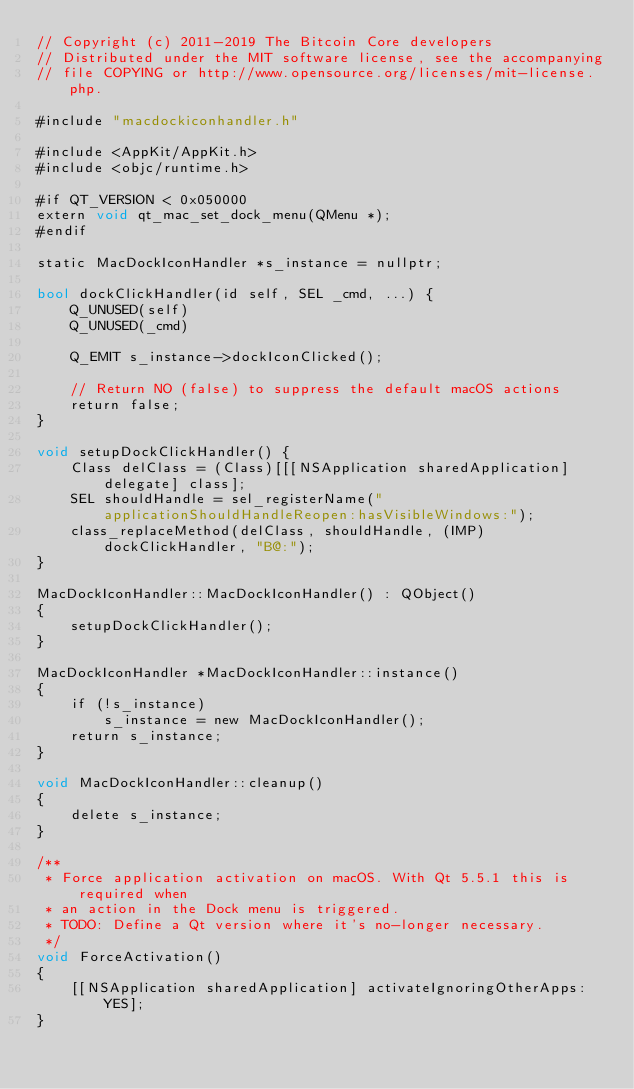Convert code to text. <code><loc_0><loc_0><loc_500><loc_500><_ObjectiveC_>// Copyright (c) 2011-2019 The Bitcoin Core developers
// Distributed under the MIT software license, see the accompanying
// file COPYING or http://www.opensource.org/licenses/mit-license.php.

#include "macdockiconhandler.h"

#include <AppKit/AppKit.h>
#include <objc/runtime.h>

#if QT_VERSION < 0x050000
extern void qt_mac_set_dock_menu(QMenu *);
#endif

static MacDockIconHandler *s_instance = nullptr;

bool dockClickHandler(id self, SEL _cmd, ...) {
    Q_UNUSED(self)
    Q_UNUSED(_cmd)

    Q_EMIT s_instance->dockIconClicked();

    // Return NO (false) to suppress the default macOS actions
    return false;
}

void setupDockClickHandler() {
    Class delClass = (Class)[[[NSApplication sharedApplication] delegate] class];
    SEL shouldHandle = sel_registerName("applicationShouldHandleReopen:hasVisibleWindows:");
    class_replaceMethod(delClass, shouldHandle, (IMP)dockClickHandler, "B@:");
}

MacDockIconHandler::MacDockIconHandler() : QObject()
{
    setupDockClickHandler();
}

MacDockIconHandler *MacDockIconHandler::instance()
{
    if (!s_instance)
        s_instance = new MacDockIconHandler();
    return s_instance;
}

void MacDockIconHandler::cleanup()
{
    delete s_instance;
}

/**
 * Force application activation on macOS. With Qt 5.5.1 this is required when
 * an action in the Dock menu is triggered.
 * TODO: Define a Qt version where it's no-longer necessary.
 */
void ForceActivation()
{
    [[NSApplication sharedApplication] activateIgnoringOtherApps:YES];
}
</code> 